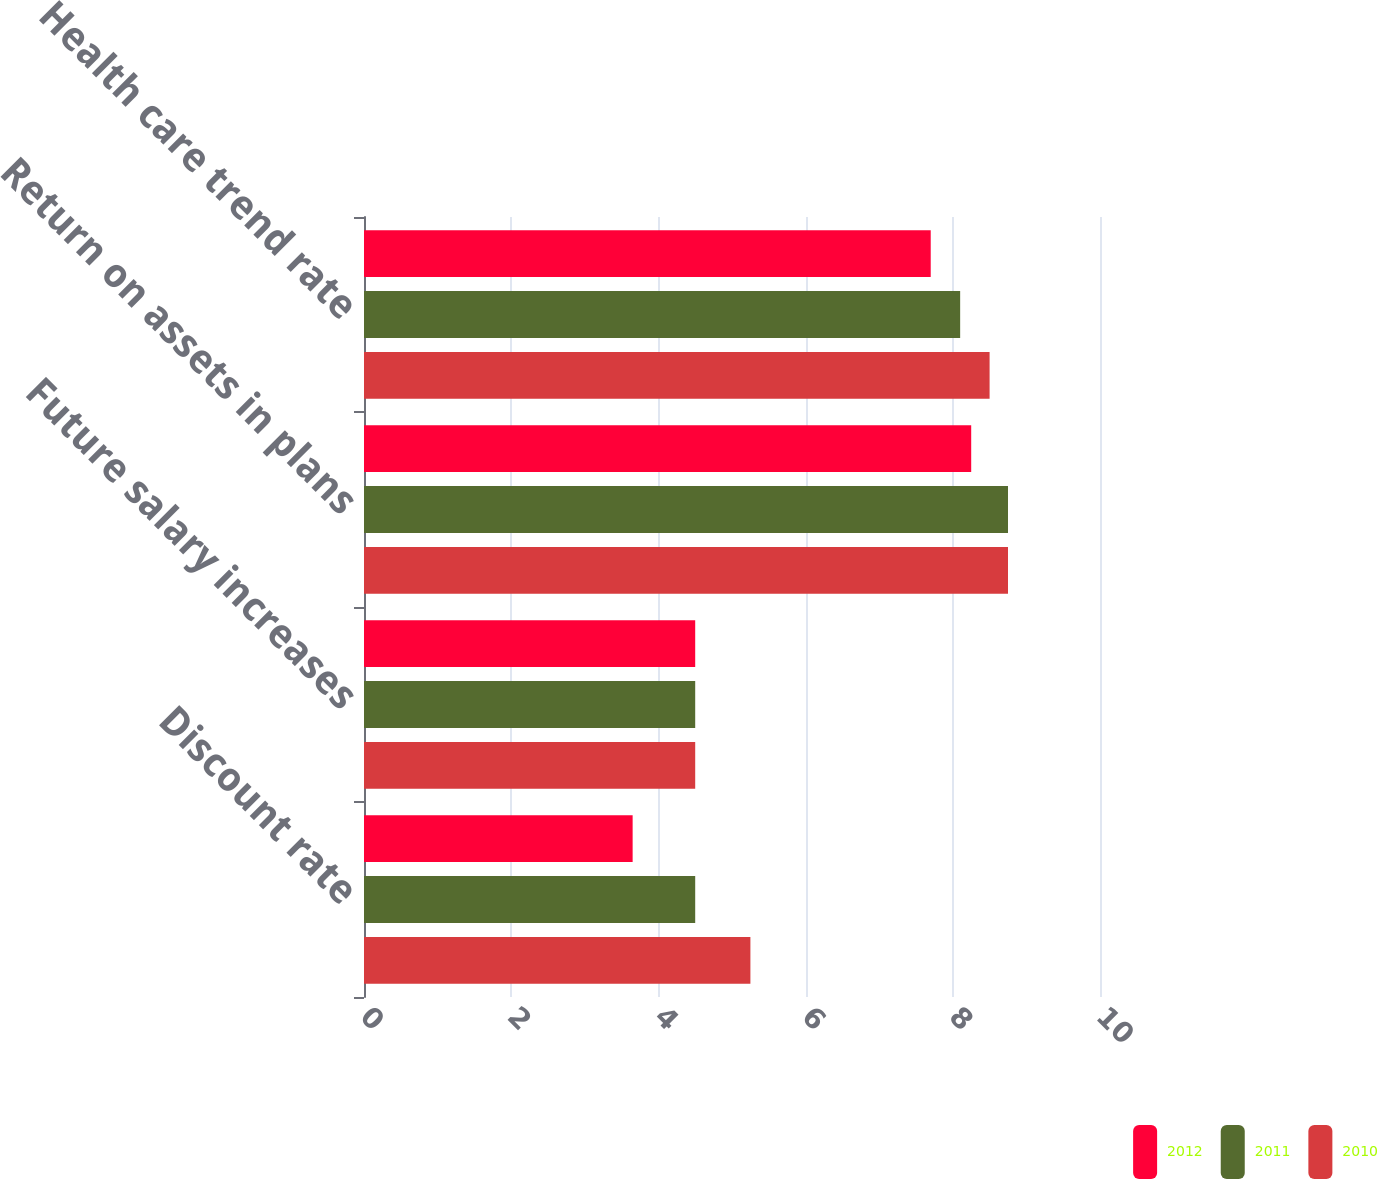<chart> <loc_0><loc_0><loc_500><loc_500><stacked_bar_chart><ecel><fcel>Discount rate<fcel>Future salary increases<fcel>Return on assets in plans<fcel>Health care trend rate<nl><fcel>2012<fcel>3.65<fcel>4.5<fcel>8.25<fcel>7.7<nl><fcel>2011<fcel>4.5<fcel>4.5<fcel>8.75<fcel>8.1<nl><fcel>2010<fcel>5.25<fcel>4.5<fcel>8.75<fcel>8.5<nl></chart> 